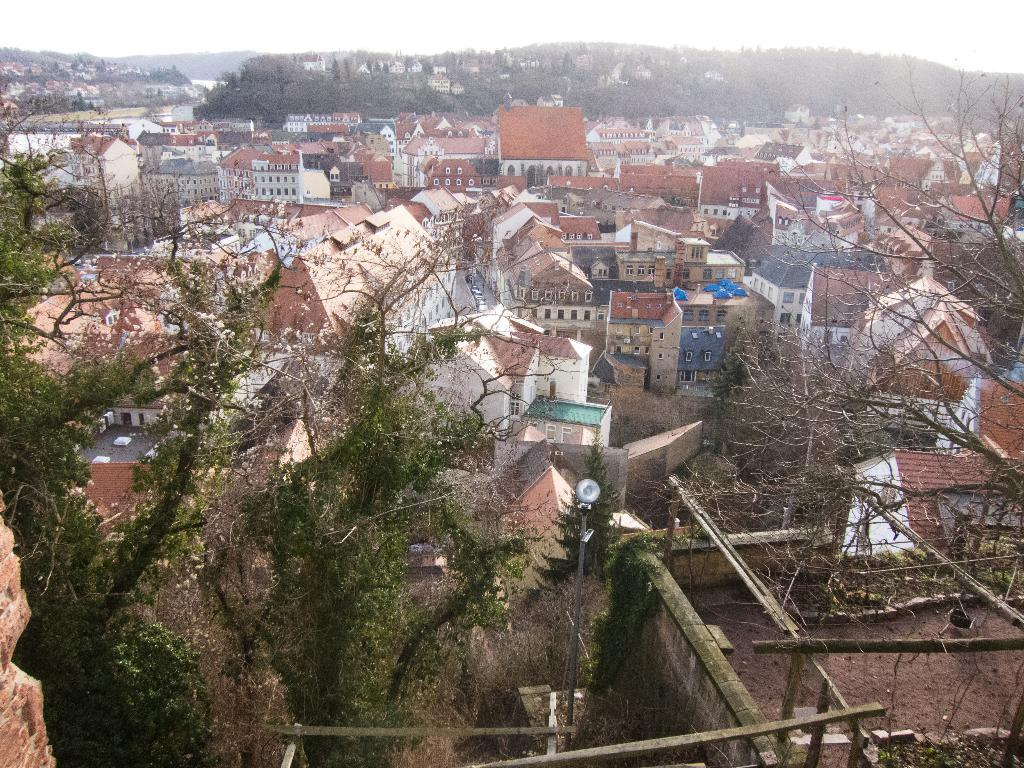What type of vegetation can be seen in the image? There are trees in the image. What structures are visible in the image? There are buildings in the image. What is visible at the top of the image? The sky is visible at the top of the image. Can you tell me how many beetles are crawling on the buildings in the image? There are no beetles present in the image; it features trees, buildings, and the sky. What type of health advice can be seen on the trees in the image? There is no health advice present on the trees in the image; it only features trees, buildings, and the sky. 